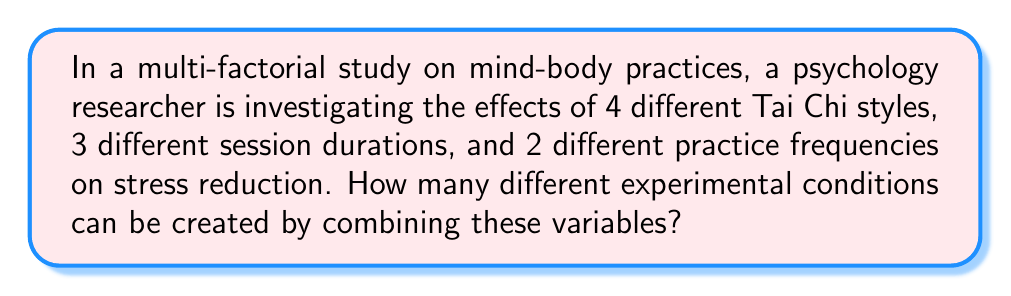Can you solve this math problem? To solve this problem, we need to use the multiplication principle of counting. This principle states that if we have multiple independent choices, the total number of possible outcomes is the product of the number of choices for each variable.

Let's break down the variables:
1. Tai Chi styles: 4 choices
2. Session durations: 3 choices
3. Practice frequencies: 2 choices

To calculate the total number of possible experimental conditions:

$$ \text{Total conditions} = 4 \times 3 \times 2 $$

$$ = 24 $$

This means that there are 24 unique combinations of Tai Chi style, session duration, and practice frequency that the researcher can investigate in their study.

Each of these 24 conditions represents a distinct experimental group, allowing the researcher to analyze how different combinations of these variables affect stress reduction in participants.
Answer: 24 